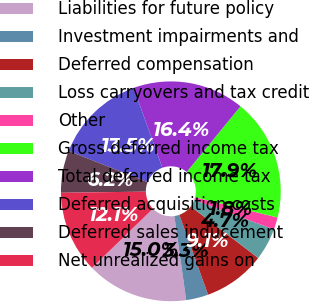<chart> <loc_0><loc_0><loc_500><loc_500><pie_chart><fcel>Liabilities for future policy<fcel>Investment impairments and<fcel>Deferred compensation<fcel>Loss carryovers and tax credit<fcel>Other<fcel>Gross deferred income tax<fcel>Total deferred income tax<fcel>Deferred acquisition costs<fcel>Deferred sales inducement<fcel>Net unrealized gains on<nl><fcel>14.97%<fcel>3.27%<fcel>9.12%<fcel>4.74%<fcel>1.81%<fcel>17.9%<fcel>16.43%<fcel>13.51%<fcel>6.2%<fcel>12.05%<nl></chart> 